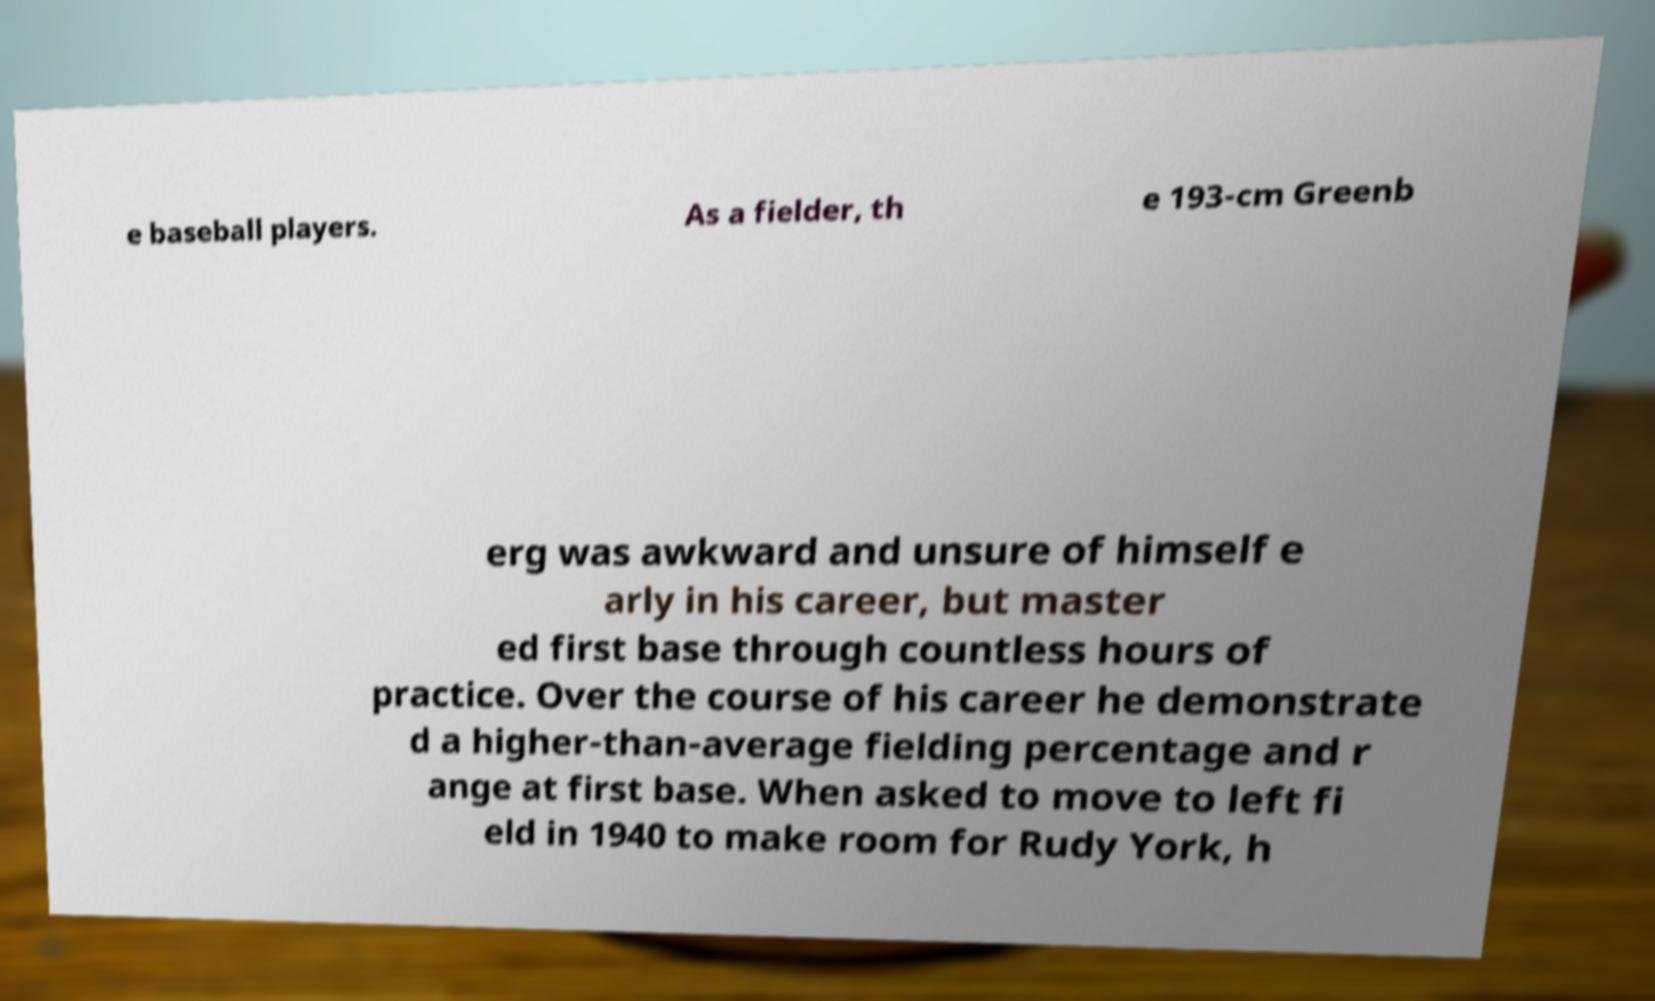Could you extract and type out the text from this image? e baseball players. As a fielder, th e 193-cm Greenb erg was awkward and unsure of himself e arly in his career, but master ed first base through countless hours of practice. Over the course of his career he demonstrate d a higher-than-average fielding percentage and r ange at first base. When asked to move to left fi eld in 1940 to make room for Rudy York, h 